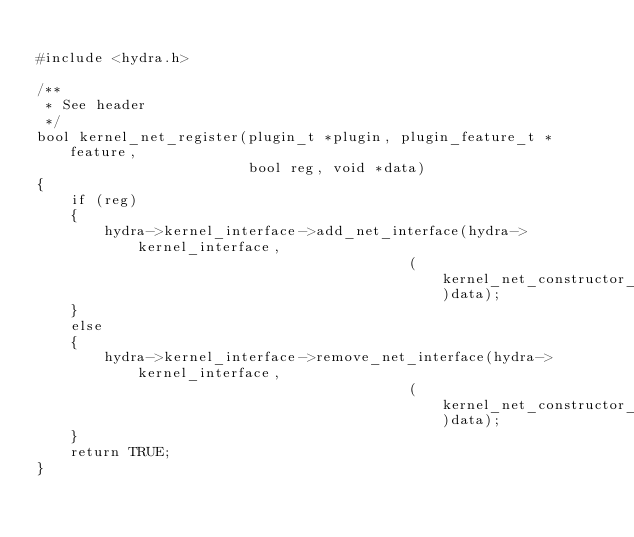Convert code to text. <code><loc_0><loc_0><loc_500><loc_500><_C_>
#include <hydra.h>

/**
 * See header
 */
bool kernel_net_register(plugin_t *plugin, plugin_feature_t *feature,
						 bool reg, void *data)
{
	if (reg)
	{
		hydra->kernel_interface->add_net_interface(hydra->kernel_interface,
											(kernel_net_constructor_t)data);
	}
	else
	{
		hydra->kernel_interface->remove_net_interface(hydra->kernel_interface,
											(kernel_net_constructor_t)data);
	}
	return TRUE;
}
</code> 